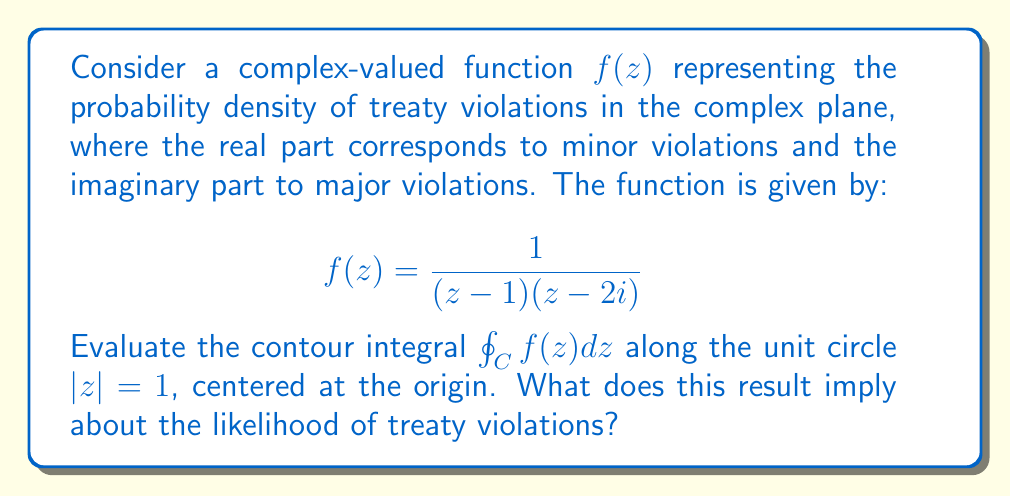Provide a solution to this math problem. To solve this problem, we'll use the Residue Theorem from complex analysis. The steps are as follows:

1) First, we need to identify the poles of the function within the contour. The function has two poles:
   - $z = 1$ (inside the unit circle)
   - $z = 2i$ (outside the unit circle)

2) We only consider the pole inside the contour, which is $z = 1$.

3) To find the residue at $z = 1$, we use the formula:
   $$\text{Res}(f, 1) = \lim_{z \to 1} (z-1)f(z) = \lim_{z \to 1} \frac{1}{z-2i} = \frac{1}{1-2i}$$

4) The Residue Theorem states that for a function $f(z)$ that is analytic except for isolated singular points inside a simple closed contour C:
   $$\oint_C f(z) dz = 2\pi i \sum \text{Res}(f, a_k)$$
   where $a_k$ are the singular points inside C.

5) Applying the theorem:
   $$\oint_C f(z) dz = 2\pi i \cdot \frac{1}{1-2i}$$

6) To simplify this complex number, we multiply numerator and denominator by the complex conjugate of the denominator:
   $$2\pi i \cdot \frac{1}{1-2i} \cdot \frac{1+2i}{1+2i} = 2\pi i \cdot \frac{1+2i}{1+4} = 2\pi i \cdot \frac{1+2i}{5}$$

7) Separating real and imaginary parts:
   $$2\pi \cdot (\frac{2}{5} + \frac{1}{5}i)$$

Interpretation: The real part ($$\frac{4\pi}{5}$$) represents the likelihood of minor treaty violations, while the imaginary part ($$\frac{2\pi}{5}$$) represents the likelihood of major violations. The magnitude of this complex number ($$\frac{2\pi}{\sqrt{5}}$$) gives an overall measure of the probability of treaty violations.
Answer: $$\oint_C f(z) dz = \frac{4\pi}{5} + \frac{2\pi}{5}i$$ 